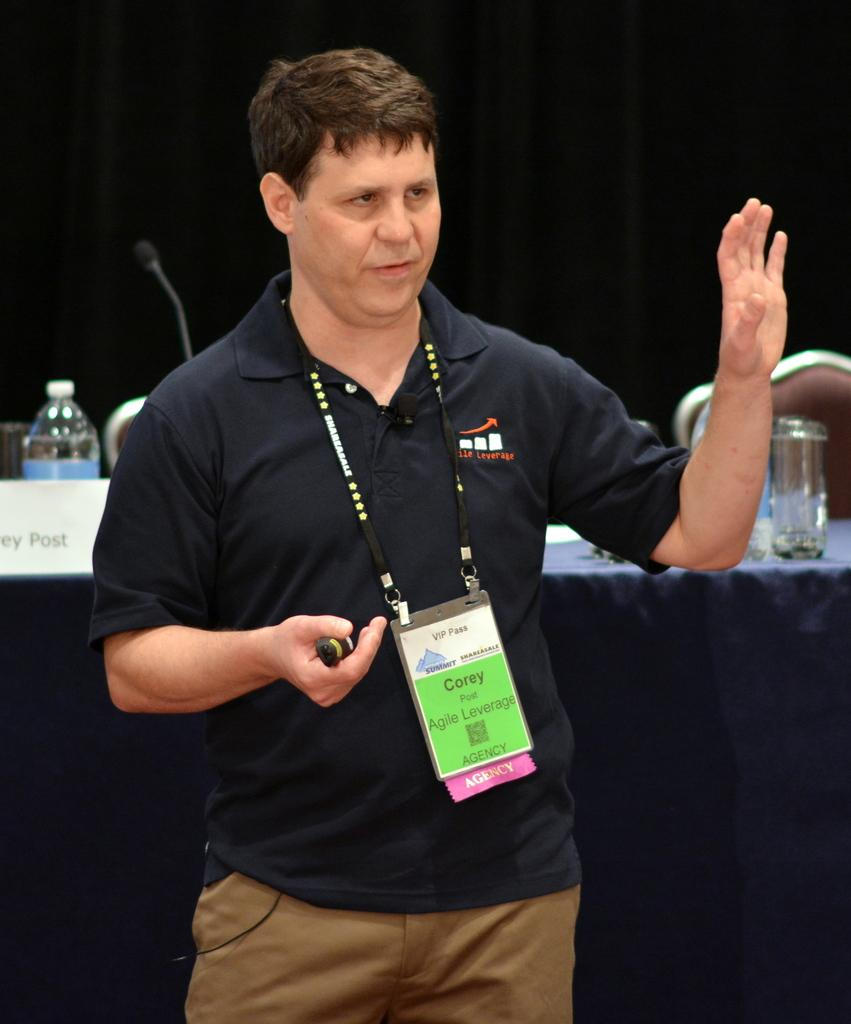What is the man in the image doing? The man is standing in the image. Can you describe what the man is wearing? The man is wearing an ID card. What can be seen in the background of the image? There is a name board, a bottle, a microphone, a glass, a table, and a chair on the table in the background of the image. What flavor of sand can be seen in the image? There is no sand present in the image, so it is not possible to determine the flavor of any sand. 